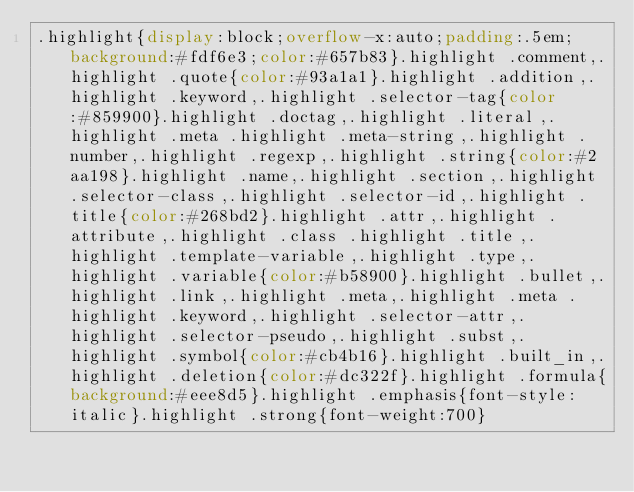<code> <loc_0><loc_0><loc_500><loc_500><_CSS_>.highlight{display:block;overflow-x:auto;padding:.5em;background:#fdf6e3;color:#657b83}.highlight .comment,.highlight .quote{color:#93a1a1}.highlight .addition,.highlight .keyword,.highlight .selector-tag{color:#859900}.highlight .doctag,.highlight .literal,.highlight .meta .highlight .meta-string,.highlight .number,.highlight .regexp,.highlight .string{color:#2aa198}.highlight .name,.highlight .section,.highlight .selector-class,.highlight .selector-id,.highlight .title{color:#268bd2}.highlight .attr,.highlight .attribute,.highlight .class .highlight .title,.highlight .template-variable,.highlight .type,.highlight .variable{color:#b58900}.highlight .bullet,.highlight .link,.highlight .meta,.highlight .meta .highlight .keyword,.highlight .selector-attr,.highlight .selector-pseudo,.highlight .subst,.highlight .symbol{color:#cb4b16}.highlight .built_in,.highlight .deletion{color:#dc322f}.highlight .formula{background:#eee8d5}.highlight .emphasis{font-style:italic}.highlight .strong{font-weight:700}</code> 